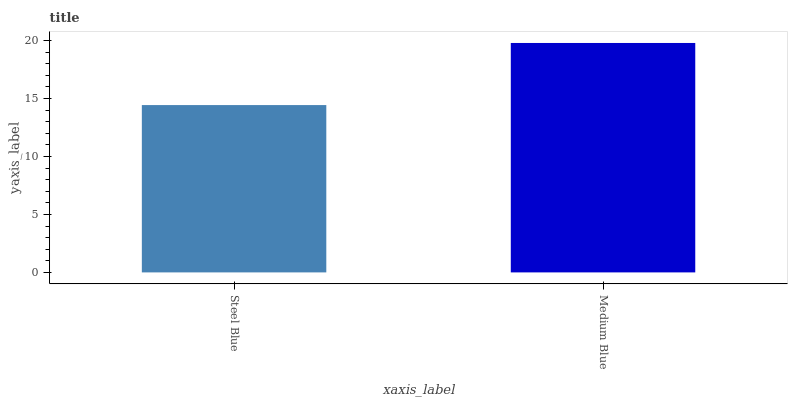Is Steel Blue the minimum?
Answer yes or no. Yes. Is Medium Blue the maximum?
Answer yes or no. Yes. Is Medium Blue the minimum?
Answer yes or no. No. Is Medium Blue greater than Steel Blue?
Answer yes or no. Yes. Is Steel Blue less than Medium Blue?
Answer yes or no. Yes. Is Steel Blue greater than Medium Blue?
Answer yes or no. No. Is Medium Blue less than Steel Blue?
Answer yes or no. No. Is Medium Blue the high median?
Answer yes or no. Yes. Is Steel Blue the low median?
Answer yes or no. Yes. Is Steel Blue the high median?
Answer yes or no. No. Is Medium Blue the low median?
Answer yes or no. No. 